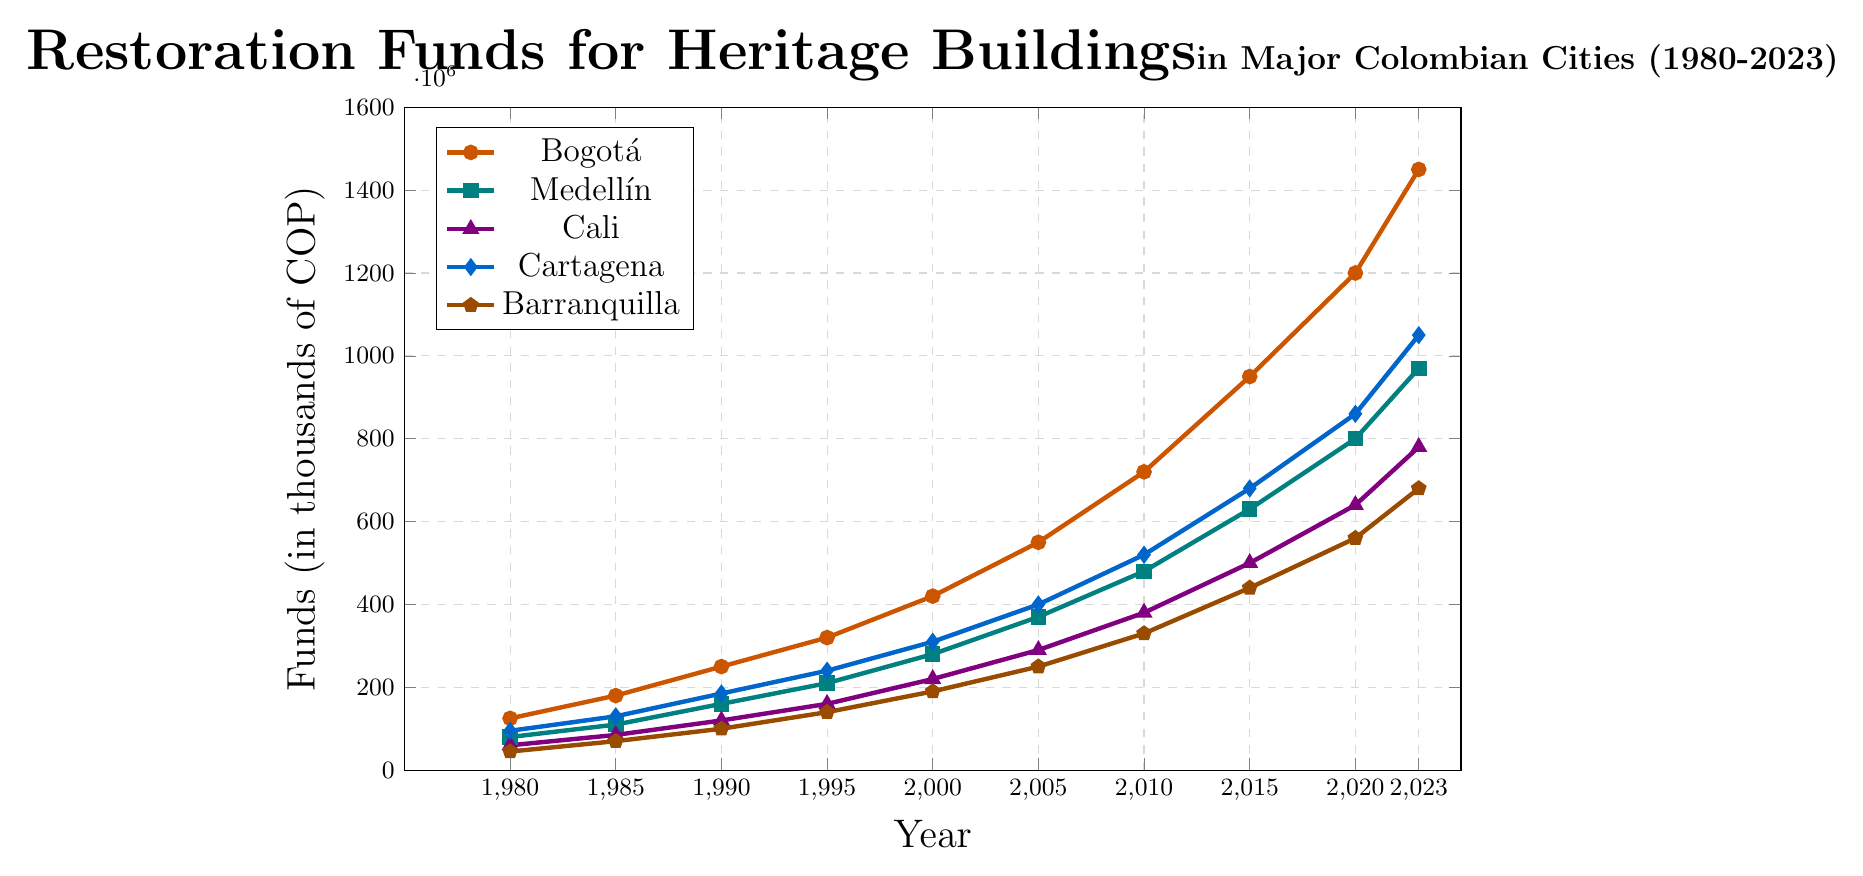What city received the highest restoration funds in 2023? Looking at the year 2023, the highest point on the graph represents Bogotá with 1,450,000 COP.
Answer: Bogotá Which city saw the smallest increase in restoration funds from 1980 to 2023? By calculating the difference in funds for each city between 1980 and 2023, the smallest increase is for Barranquilla, which rose from 45,000 to 680,000 COP, resulting in an increase of 635,000 COP.
Answer: Barranquilla In what year did Cali first receive more funds than Cartagena? Comparing the values for each year, 2020 is the first year where Cali (640,000 COP) surpasses Cartagena (860,000 COP).
Answer: 2020 How much total restoration funds were allocated to Medellín between 2000 and 2023? Adding the values for Medellín from 2000 (280,000), 2005 (370,000), 2010 (480,000), 2015 (630,000), 2020 (800,000), to 2023 (970,000), the sum is 3,530,000 COP.
Answer: 3,530,000 COP Which city has the steepest increase in restoration funds from 2010 to 2015? Observing the slope of the lines between 2010 and 2015, Bogotá has the steepest increase from 720,000 to 950,000 COP, an increase of 230,000 COP.
Answer: Bogotá What's the average restoration funds allocated to Cartagena between 1995 and 2005? Summing the values for Cartagena in 1995 (240,000), 2000 (310,000), and 2005 (400,000) gives a total of 950,000. Dividing by 3, the average is approximately 316,667 COP.
Answer: 316,667 COP Compare the restoration funds of Bogotá and Cali in 2005. Which city received more, and by how much? In 2005, Bogotá received 550,000 COP while Cali received 290,000 COP. The difference is 550,000 - 290,000 = 260,000 COP.
Answer: Bogotá by 260,000 COP What is the trend of restoration funds for Barranquilla over the years? Observing the line for Barranquilla from 1980 to 2023, there is a consistent upward trend, indicating a steady increase in restoration funds over the years.
Answer: Upward trend How do the restoration funds for Bogotá in 2000 compare to those for Medellín in 2010? In 2000, Bogotá received 420,000 COP, while Medellín in 2010 received 480,000 COP. Medellín received 60,000 COP more.
Answer: Medellín by 60,000 COP What is the total difference in restoration funds between 1980 and 2023 for Bogotá? The funds for Bogotá in 1980 were 125,000 COP and in 2023 were 1,450,000 COP. The difference is 1,450,000 - 125,000 = 1,325,000 COP.
Answer: 1,325,000 COP 